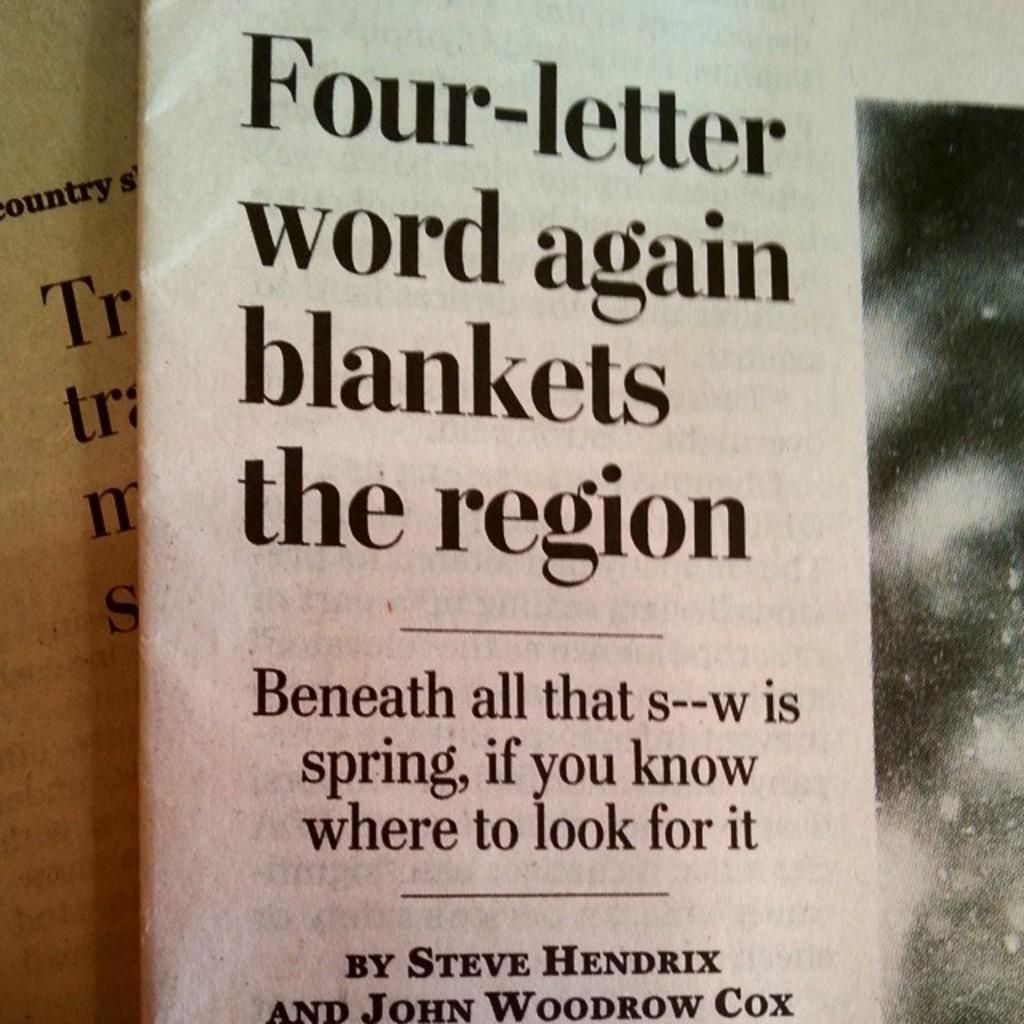What is the word referenced as a four-letter word?
Keep it short and to the point. Snow. Who wrote this article?
Your answer should be compact. Steve hendrix and john woodrow cox. 